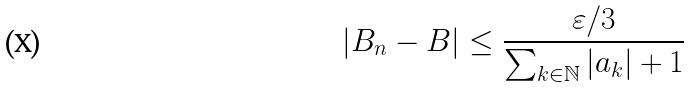Convert formula to latex. <formula><loc_0><loc_0><loc_500><loc_500>| B _ { n } - B | \leq { \frac { \varepsilon / 3 } { \sum _ { k \in { \mathbb { N } } } | a _ { k } | + 1 } }</formula> 